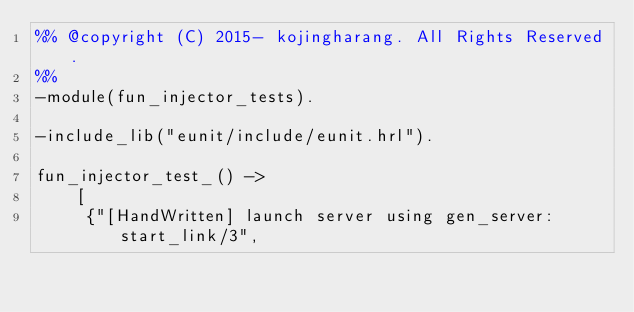Convert code to text. <code><loc_0><loc_0><loc_500><loc_500><_Erlang_>%% @copyright (C) 2015- kojingharang. All Rights Reserved.
%%
-module(fun_injector_tests).

-include_lib("eunit/include/eunit.hrl").

fun_injector_test_() ->
    [
     {"[HandWritten] launch server using gen_server:start_link/3",</code> 